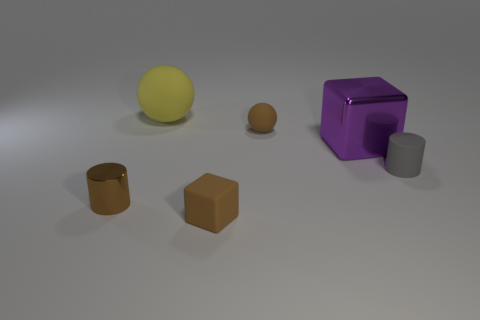Add 2 brown matte cylinders. How many objects exist? 8 Subtract all yellow balls. How many balls are left? 1 Subtract all cyan balls. How many brown cubes are left? 1 Subtract all small gray rubber things. Subtract all large rubber spheres. How many objects are left? 4 Add 5 small rubber cylinders. How many small rubber cylinders are left? 6 Add 3 gray objects. How many gray objects exist? 4 Subtract 0 green cylinders. How many objects are left? 6 Subtract all spheres. How many objects are left? 4 Subtract 2 cubes. How many cubes are left? 0 Subtract all yellow blocks. Subtract all blue cylinders. How many blocks are left? 2 